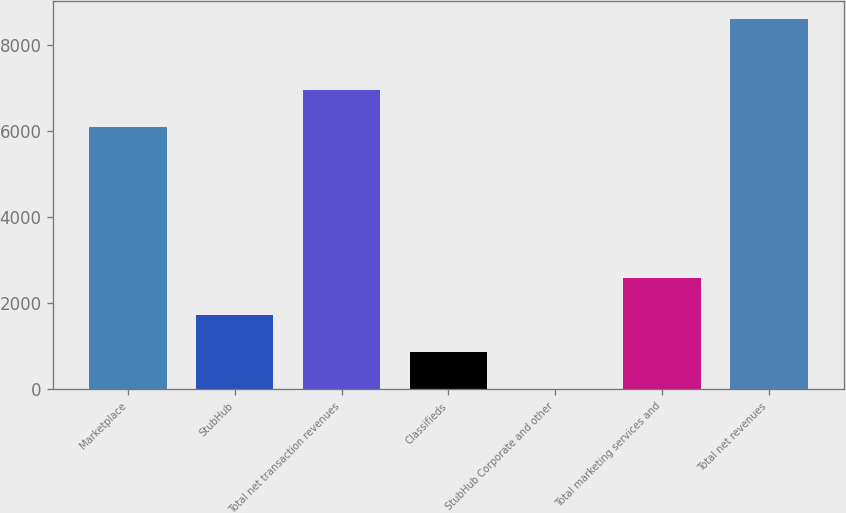<chart> <loc_0><loc_0><loc_500><loc_500><bar_chart><fcel>Marketplace<fcel>StubHub<fcel>Total net transaction revenues<fcel>Classifieds<fcel>StubHub Corporate and other<fcel>Total marketing services and<fcel>Total net revenues<nl><fcel>6103<fcel>1732<fcel>6960.5<fcel>874.5<fcel>17<fcel>2589.5<fcel>8592<nl></chart> 